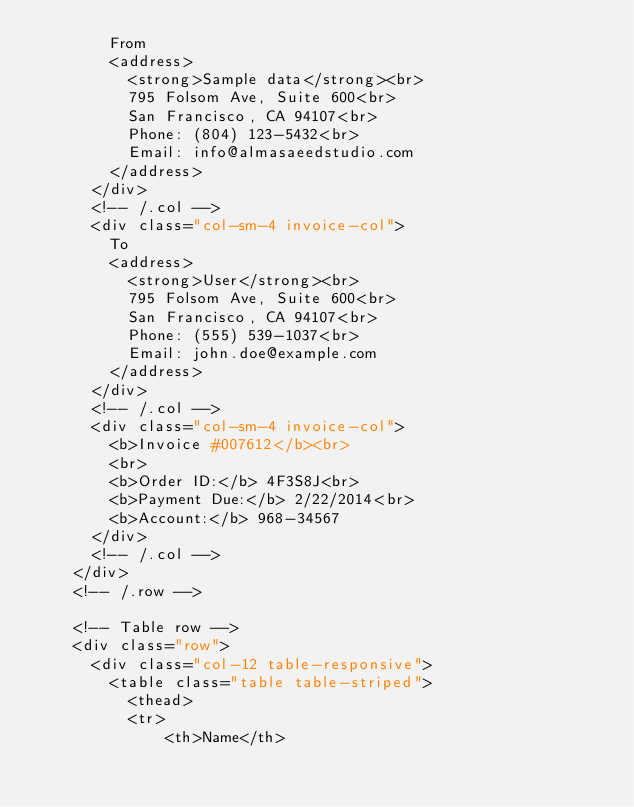Convert code to text. <code><loc_0><loc_0><loc_500><loc_500><_PHP_>        From
        <address>
          <strong>Sample data</strong><br>
          795 Folsom Ave, Suite 600<br>
          San Francisco, CA 94107<br>
          Phone: (804) 123-5432<br>
          Email: info@almasaeedstudio.com
        </address>
      </div>
      <!-- /.col -->
      <div class="col-sm-4 invoice-col">
        To
        <address>
          <strong>User</strong><br>
          795 Folsom Ave, Suite 600<br>
          San Francisco, CA 94107<br>
          Phone: (555) 539-1037<br>
          Email: john.doe@example.com
        </address>
      </div>
      <!-- /.col -->
      <div class="col-sm-4 invoice-col">
        <b>Invoice #007612</b><br>
        <br>
        <b>Order ID:</b> 4F3S8J<br>
        <b>Payment Due:</b> 2/22/2014<br>
        <b>Account:</b> 968-34567
      </div>
      <!-- /.col -->
    </div>
    <!-- /.row -->

    <!-- Table row -->
    <div class="row">
      <div class="col-12 table-responsive">
        <table class="table table-striped">
          <thead>
          <tr>
              <th>Name</th></code> 